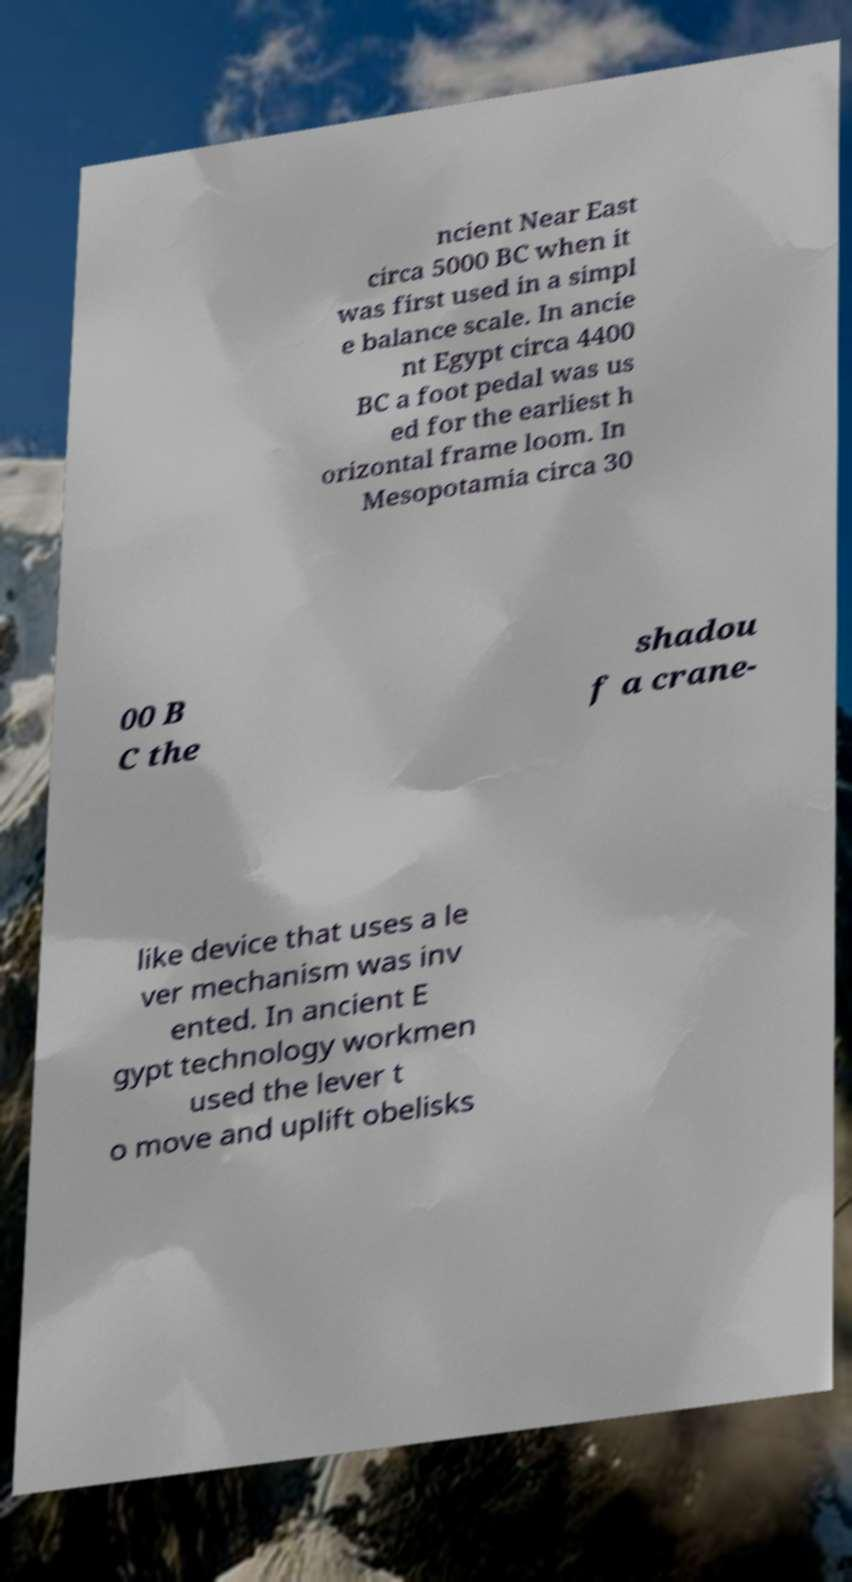Could you assist in decoding the text presented in this image and type it out clearly? ncient Near East circa 5000 BC when it was first used in a simpl e balance scale. In ancie nt Egypt circa 4400 BC a foot pedal was us ed for the earliest h orizontal frame loom. In Mesopotamia circa 30 00 B C the shadou f a crane- like device that uses a le ver mechanism was inv ented. In ancient E gypt technology workmen used the lever t o move and uplift obelisks 